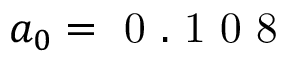<formula> <loc_0><loc_0><loc_500><loc_500>a _ { 0 } = 0 . 1 0 8</formula> 